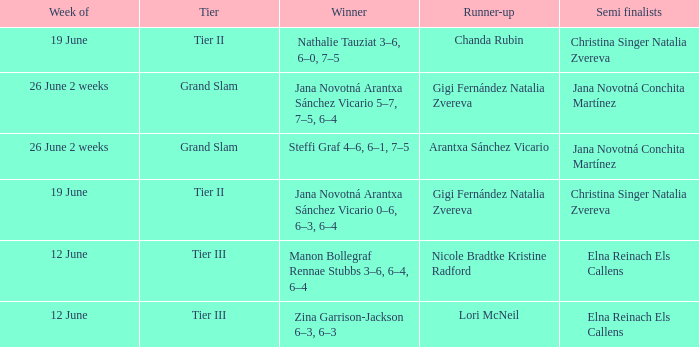In which week is the winner listed as Jana Novotná Arantxa Sánchez Vicario 5–7, 7–5, 6–4? 26 June 2 weeks. 